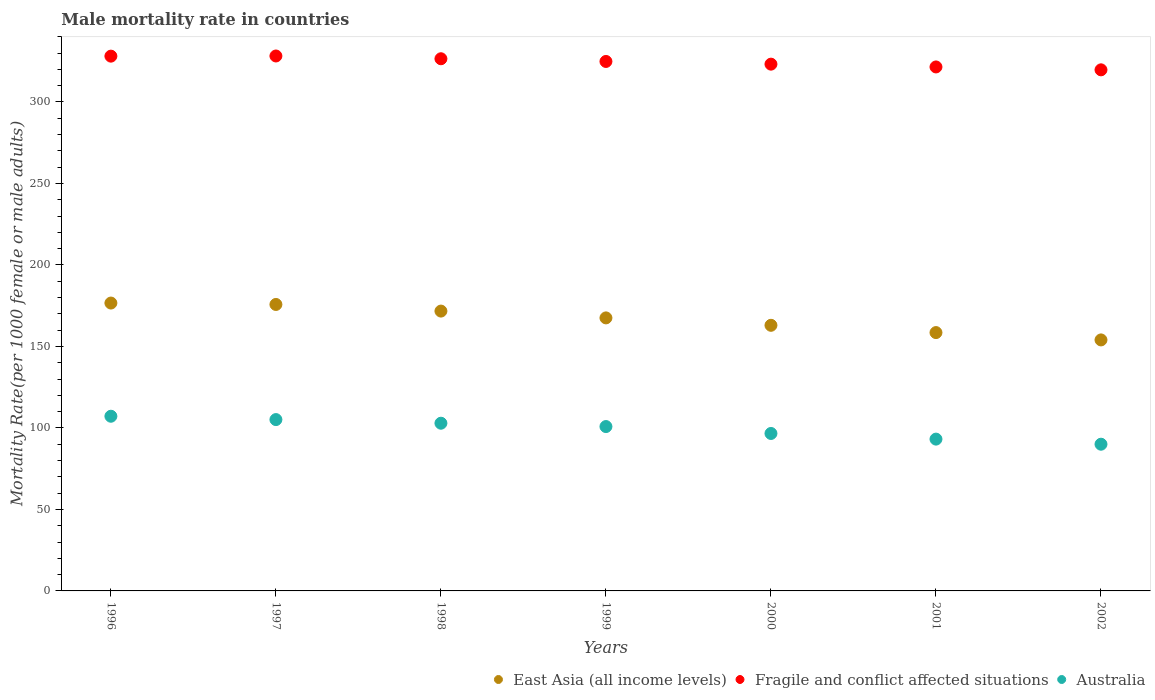How many different coloured dotlines are there?
Your response must be concise. 3. Is the number of dotlines equal to the number of legend labels?
Your response must be concise. Yes. What is the male mortality rate in Australia in 2001?
Your response must be concise. 93.13. Across all years, what is the maximum male mortality rate in Australia?
Provide a short and direct response. 107.17. Across all years, what is the minimum male mortality rate in East Asia (all income levels)?
Provide a short and direct response. 154. In which year was the male mortality rate in East Asia (all income levels) maximum?
Your response must be concise. 1996. What is the total male mortality rate in Australia in the graph?
Provide a succinct answer. 695.75. What is the difference between the male mortality rate in Australia in 1996 and that in 2000?
Offer a terse response. 10.57. What is the difference between the male mortality rate in Fragile and conflict affected situations in 1997 and the male mortality rate in Australia in 1999?
Your answer should be compact. 227.35. What is the average male mortality rate in Australia per year?
Your response must be concise. 99.39. In the year 2000, what is the difference between the male mortality rate in East Asia (all income levels) and male mortality rate in Fragile and conflict affected situations?
Keep it short and to the point. -160.22. What is the ratio of the male mortality rate in East Asia (all income levels) in 1997 to that in 1999?
Provide a short and direct response. 1.05. What is the difference between the highest and the second highest male mortality rate in East Asia (all income levels)?
Your answer should be compact. 0.86. What is the difference between the highest and the lowest male mortality rate in East Asia (all income levels)?
Offer a very short reply. 22.61. Is the sum of the male mortality rate in East Asia (all income levels) in 1996 and 1997 greater than the maximum male mortality rate in Australia across all years?
Ensure brevity in your answer.  Yes. Is it the case that in every year, the sum of the male mortality rate in Australia and male mortality rate in Fragile and conflict affected situations  is greater than the male mortality rate in East Asia (all income levels)?
Make the answer very short. Yes. Does the male mortality rate in East Asia (all income levels) monotonically increase over the years?
Provide a succinct answer. No. Is the male mortality rate in East Asia (all income levels) strictly less than the male mortality rate in Australia over the years?
Provide a succinct answer. No. How many years are there in the graph?
Keep it short and to the point. 7. What is the difference between two consecutive major ticks on the Y-axis?
Keep it short and to the point. 50. Are the values on the major ticks of Y-axis written in scientific E-notation?
Your answer should be very brief. No. Does the graph contain any zero values?
Your answer should be compact. No. Does the graph contain grids?
Give a very brief answer. No. Where does the legend appear in the graph?
Your answer should be very brief. Bottom right. What is the title of the graph?
Keep it short and to the point. Male mortality rate in countries. What is the label or title of the Y-axis?
Your response must be concise. Mortality Rate(per 1000 female or male adults). What is the Mortality Rate(per 1000 female or male adults) in East Asia (all income levels) in 1996?
Give a very brief answer. 176.61. What is the Mortality Rate(per 1000 female or male adults) of Fragile and conflict affected situations in 1996?
Keep it short and to the point. 328.09. What is the Mortality Rate(per 1000 female or male adults) in Australia in 1996?
Give a very brief answer. 107.17. What is the Mortality Rate(per 1000 female or male adults) in East Asia (all income levels) in 1997?
Your answer should be very brief. 175.75. What is the Mortality Rate(per 1000 female or male adults) in Fragile and conflict affected situations in 1997?
Provide a short and direct response. 328.19. What is the Mortality Rate(per 1000 female or male adults) of Australia in 1997?
Provide a succinct answer. 105.12. What is the Mortality Rate(per 1000 female or male adults) in East Asia (all income levels) in 1998?
Offer a very short reply. 171.68. What is the Mortality Rate(per 1000 female or male adults) of Fragile and conflict affected situations in 1998?
Your answer should be very brief. 326.5. What is the Mortality Rate(per 1000 female or male adults) in Australia in 1998?
Your answer should be compact. 102.89. What is the Mortality Rate(per 1000 female or male adults) in East Asia (all income levels) in 1999?
Your response must be concise. 167.51. What is the Mortality Rate(per 1000 female or male adults) in Fragile and conflict affected situations in 1999?
Provide a short and direct response. 324.84. What is the Mortality Rate(per 1000 female or male adults) in Australia in 1999?
Ensure brevity in your answer.  100.84. What is the Mortality Rate(per 1000 female or male adults) of East Asia (all income levels) in 2000?
Make the answer very short. 162.96. What is the Mortality Rate(per 1000 female or male adults) of Fragile and conflict affected situations in 2000?
Give a very brief answer. 323.18. What is the Mortality Rate(per 1000 female or male adults) in Australia in 2000?
Offer a terse response. 96.6. What is the Mortality Rate(per 1000 female or male adults) in East Asia (all income levels) in 2001?
Ensure brevity in your answer.  158.49. What is the Mortality Rate(per 1000 female or male adults) of Fragile and conflict affected situations in 2001?
Make the answer very short. 321.47. What is the Mortality Rate(per 1000 female or male adults) of Australia in 2001?
Ensure brevity in your answer.  93.13. What is the Mortality Rate(per 1000 female or male adults) in East Asia (all income levels) in 2002?
Offer a very short reply. 154. What is the Mortality Rate(per 1000 female or male adults) in Fragile and conflict affected situations in 2002?
Keep it short and to the point. 319.7. What is the Mortality Rate(per 1000 female or male adults) of Australia in 2002?
Your answer should be compact. 90.01. Across all years, what is the maximum Mortality Rate(per 1000 female or male adults) in East Asia (all income levels)?
Make the answer very short. 176.61. Across all years, what is the maximum Mortality Rate(per 1000 female or male adults) of Fragile and conflict affected situations?
Provide a short and direct response. 328.19. Across all years, what is the maximum Mortality Rate(per 1000 female or male adults) of Australia?
Give a very brief answer. 107.17. Across all years, what is the minimum Mortality Rate(per 1000 female or male adults) in East Asia (all income levels)?
Your answer should be very brief. 154. Across all years, what is the minimum Mortality Rate(per 1000 female or male adults) in Fragile and conflict affected situations?
Offer a terse response. 319.7. Across all years, what is the minimum Mortality Rate(per 1000 female or male adults) in Australia?
Your response must be concise. 90.01. What is the total Mortality Rate(per 1000 female or male adults) of East Asia (all income levels) in the graph?
Ensure brevity in your answer.  1167. What is the total Mortality Rate(per 1000 female or male adults) of Fragile and conflict affected situations in the graph?
Your answer should be very brief. 2271.97. What is the total Mortality Rate(per 1000 female or male adults) of Australia in the graph?
Ensure brevity in your answer.  695.75. What is the difference between the Mortality Rate(per 1000 female or male adults) of East Asia (all income levels) in 1996 and that in 1997?
Your answer should be very brief. 0.86. What is the difference between the Mortality Rate(per 1000 female or male adults) of Fragile and conflict affected situations in 1996 and that in 1997?
Ensure brevity in your answer.  -0.1. What is the difference between the Mortality Rate(per 1000 female or male adults) of Australia in 1996 and that in 1997?
Provide a succinct answer. 2.05. What is the difference between the Mortality Rate(per 1000 female or male adults) of East Asia (all income levels) in 1996 and that in 1998?
Your answer should be very brief. 4.93. What is the difference between the Mortality Rate(per 1000 female or male adults) in Fragile and conflict affected situations in 1996 and that in 1998?
Make the answer very short. 1.6. What is the difference between the Mortality Rate(per 1000 female or male adults) in Australia in 1996 and that in 1998?
Offer a very short reply. 4.28. What is the difference between the Mortality Rate(per 1000 female or male adults) of East Asia (all income levels) in 1996 and that in 1999?
Your response must be concise. 9.1. What is the difference between the Mortality Rate(per 1000 female or male adults) in Fragile and conflict affected situations in 1996 and that in 1999?
Provide a succinct answer. 3.26. What is the difference between the Mortality Rate(per 1000 female or male adults) in Australia in 1996 and that in 1999?
Your answer should be very brief. 6.33. What is the difference between the Mortality Rate(per 1000 female or male adults) in East Asia (all income levels) in 1996 and that in 2000?
Provide a succinct answer. 13.65. What is the difference between the Mortality Rate(per 1000 female or male adults) of Fragile and conflict affected situations in 1996 and that in 2000?
Offer a very short reply. 4.91. What is the difference between the Mortality Rate(per 1000 female or male adults) of Australia in 1996 and that in 2000?
Your response must be concise. 10.57. What is the difference between the Mortality Rate(per 1000 female or male adults) in East Asia (all income levels) in 1996 and that in 2001?
Your answer should be very brief. 18.12. What is the difference between the Mortality Rate(per 1000 female or male adults) of Fragile and conflict affected situations in 1996 and that in 2001?
Provide a succinct answer. 6.62. What is the difference between the Mortality Rate(per 1000 female or male adults) in Australia in 1996 and that in 2001?
Make the answer very short. 14.03. What is the difference between the Mortality Rate(per 1000 female or male adults) in East Asia (all income levels) in 1996 and that in 2002?
Your response must be concise. 22.61. What is the difference between the Mortality Rate(per 1000 female or male adults) of Fragile and conflict affected situations in 1996 and that in 2002?
Give a very brief answer. 8.4. What is the difference between the Mortality Rate(per 1000 female or male adults) in Australia in 1996 and that in 2002?
Ensure brevity in your answer.  17.16. What is the difference between the Mortality Rate(per 1000 female or male adults) of East Asia (all income levels) in 1997 and that in 1998?
Provide a succinct answer. 4.07. What is the difference between the Mortality Rate(per 1000 female or male adults) in Fragile and conflict affected situations in 1997 and that in 1998?
Ensure brevity in your answer.  1.7. What is the difference between the Mortality Rate(per 1000 female or male adults) of Australia in 1997 and that in 1998?
Keep it short and to the point. 2.23. What is the difference between the Mortality Rate(per 1000 female or male adults) in East Asia (all income levels) in 1997 and that in 1999?
Provide a short and direct response. 8.24. What is the difference between the Mortality Rate(per 1000 female or male adults) in Fragile and conflict affected situations in 1997 and that in 1999?
Offer a terse response. 3.35. What is the difference between the Mortality Rate(per 1000 female or male adults) in Australia in 1997 and that in 1999?
Your response must be concise. 4.28. What is the difference between the Mortality Rate(per 1000 female or male adults) of East Asia (all income levels) in 1997 and that in 2000?
Keep it short and to the point. 12.79. What is the difference between the Mortality Rate(per 1000 female or male adults) in Fragile and conflict affected situations in 1997 and that in 2000?
Ensure brevity in your answer.  5.01. What is the difference between the Mortality Rate(per 1000 female or male adults) of Australia in 1997 and that in 2000?
Provide a succinct answer. 8.52. What is the difference between the Mortality Rate(per 1000 female or male adults) in East Asia (all income levels) in 1997 and that in 2001?
Provide a short and direct response. 17.25. What is the difference between the Mortality Rate(per 1000 female or male adults) of Fragile and conflict affected situations in 1997 and that in 2001?
Keep it short and to the point. 6.72. What is the difference between the Mortality Rate(per 1000 female or male adults) of Australia in 1997 and that in 2001?
Your answer should be very brief. 11.99. What is the difference between the Mortality Rate(per 1000 female or male adults) in East Asia (all income levels) in 1997 and that in 2002?
Make the answer very short. 21.75. What is the difference between the Mortality Rate(per 1000 female or male adults) of Fragile and conflict affected situations in 1997 and that in 2002?
Give a very brief answer. 8.5. What is the difference between the Mortality Rate(per 1000 female or male adults) of Australia in 1997 and that in 2002?
Give a very brief answer. 15.11. What is the difference between the Mortality Rate(per 1000 female or male adults) in East Asia (all income levels) in 1998 and that in 1999?
Your answer should be compact. 4.17. What is the difference between the Mortality Rate(per 1000 female or male adults) in Fragile and conflict affected situations in 1998 and that in 1999?
Offer a terse response. 1.66. What is the difference between the Mortality Rate(per 1000 female or male adults) of Australia in 1998 and that in 1999?
Ensure brevity in your answer.  2.05. What is the difference between the Mortality Rate(per 1000 female or male adults) in East Asia (all income levels) in 1998 and that in 2000?
Ensure brevity in your answer.  8.72. What is the difference between the Mortality Rate(per 1000 female or male adults) in Fragile and conflict affected situations in 1998 and that in 2000?
Your answer should be very brief. 3.32. What is the difference between the Mortality Rate(per 1000 female or male adults) of Australia in 1998 and that in 2000?
Offer a very short reply. 6.29. What is the difference between the Mortality Rate(per 1000 female or male adults) in East Asia (all income levels) in 1998 and that in 2001?
Your response must be concise. 13.19. What is the difference between the Mortality Rate(per 1000 female or male adults) of Fragile and conflict affected situations in 1998 and that in 2001?
Ensure brevity in your answer.  5.03. What is the difference between the Mortality Rate(per 1000 female or male adults) in Australia in 1998 and that in 2001?
Offer a terse response. 9.75. What is the difference between the Mortality Rate(per 1000 female or male adults) of East Asia (all income levels) in 1998 and that in 2002?
Offer a terse response. 17.68. What is the difference between the Mortality Rate(per 1000 female or male adults) of Fragile and conflict affected situations in 1998 and that in 2002?
Give a very brief answer. 6.8. What is the difference between the Mortality Rate(per 1000 female or male adults) in Australia in 1998 and that in 2002?
Provide a short and direct response. 12.88. What is the difference between the Mortality Rate(per 1000 female or male adults) in East Asia (all income levels) in 1999 and that in 2000?
Your response must be concise. 4.55. What is the difference between the Mortality Rate(per 1000 female or male adults) in Fragile and conflict affected situations in 1999 and that in 2000?
Give a very brief answer. 1.66. What is the difference between the Mortality Rate(per 1000 female or male adults) of Australia in 1999 and that in 2000?
Give a very brief answer. 4.24. What is the difference between the Mortality Rate(per 1000 female or male adults) of East Asia (all income levels) in 1999 and that in 2001?
Make the answer very short. 9.02. What is the difference between the Mortality Rate(per 1000 female or male adults) of Fragile and conflict affected situations in 1999 and that in 2001?
Keep it short and to the point. 3.37. What is the difference between the Mortality Rate(per 1000 female or male adults) in Australia in 1999 and that in 2001?
Offer a very short reply. 7.71. What is the difference between the Mortality Rate(per 1000 female or male adults) in East Asia (all income levels) in 1999 and that in 2002?
Offer a terse response. 13.51. What is the difference between the Mortality Rate(per 1000 female or male adults) in Fragile and conflict affected situations in 1999 and that in 2002?
Your answer should be very brief. 5.14. What is the difference between the Mortality Rate(per 1000 female or male adults) in Australia in 1999 and that in 2002?
Your answer should be compact. 10.83. What is the difference between the Mortality Rate(per 1000 female or male adults) of East Asia (all income levels) in 2000 and that in 2001?
Give a very brief answer. 4.47. What is the difference between the Mortality Rate(per 1000 female or male adults) of Fragile and conflict affected situations in 2000 and that in 2001?
Your response must be concise. 1.71. What is the difference between the Mortality Rate(per 1000 female or male adults) of Australia in 2000 and that in 2001?
Provide a succinct answer. 3.46. What is the difference between the Mortality Rate(per 1000 female or male adults) in East Asia (all income levels) in 2000 and that in 2002?
Provide a short and direct response. 8.96. What is the difference between the Mortality Rate(per 1000 female or male adults) of Fragile and conflict affected situations in 2000 and that in 2002?
Your response must be concise. 3.49. What is the difference between the Mortality Rate(per 1000 female or male adults) in Australia in 2000 and that in 2002?
Offer a very short reply. 6.59. What is the difference between the Mortality Rate(per 1000 female or male adults) in East Asia (all income levels) in 2001 and that in 2002?
Your response must be concise. 4.5. What is the difference between the Mortality Rate(per 1000 female or male adults) in Fragile and conflict affected situations in 2001 and that in 2002?
Provide a succinct answer. 1.77. What is the difference between the Mortality Rate(per 1000 female or male adults) in Australia in 2001 and that in 2002?
Provide a short and direct response. 3.13. What is the difference between the Mortality Rate(per 1000 female or male adults) of East Asia (all income levels) in 1996 and the Mortality Rate(per 1000 female or male adults) of Fragile and conflict affected situations in 1997?
Keep it short and to the point. -151.58. What is the difference between the Mortality Rate(per 1000 female or male adults) in East Asia (all income levels) in 1996 and the Mortality Rate(per 1000 female or male adults) in Australia in 1997?
Ensure brevity in your answer.  71.49. What is the difference between the Mortality Rate(per 1000 female or male adults) in Fragile and conflict affected situations in 1996 and the Mortality Rate(per 1000 female or male adults) in Australia in 1997?
Offer a terse response. 222.97. What is the difference between the Mortality Rate(per 1000 female or male adults) of East Asia (all income levels) in 1996 and the Mortality Rate(per 1000 female or male adults) of Fragile and conflict affected situations in 1998?
Ensure brevity in your answer.  -149.89. What is the difference between the Mortality Rate(per 1000 female or male adults) of East Asia (all income levels) in 1996 and the Mortality Rate(per 1000 female or male adults) of Australia in 1998?
Your answer should be compact. 73.72. What is the difference between the Mortality Rate(per 1000 female or male adults) in Fragile and conflict affected situations in 1996 and the Mortality Rate(per 1000 female or male adults) in Australia in 1998?
Offer a terse response. 225.21. What is the difference between the Mortality Rate(per 1000 female or male adults) of East Asia (all income levels) in 1996 and the Mortality Rate(per 1000 female or male adults) of Fragile and conflict affected situations in 1999?
Offer a very short reply. -148.23. What is the difference between the Mortality Rate(per 1000 female or male adults) in East Asia (all income levels) in 1996 and the Mortality Rate(per 1000 female or male adults) in Australia in 1999?
Give a very brief answer. 75.77. What is the difference between the Mortality Rate(per 1000 female or male adults) in Fragile and conflict affected situations in 1996 and the Mortality Rate(per 1000 female or male adults) in Australia in 1999?
Provide a succinct answer. 227.25. What is the difference between the Mortality Rate(per 1000 female or male adults) in East Asia (all income levels) in 1996 and the Mortality Rate(per 1000 female or male adults) in Fragile and conflict affected situations in 2000?
Provide a succinct answer. -146.57. What is the difference between the Mortality Rate(per 1000 female or male adults) of East Asia (all income levels) in 1996 and the Mortality Rate(per 1000 female or male adults) of Australia in 2000?
Your answer should be compact. 80.01. What is the difference between the Mortality Rate(per 1000 female or male adults) of Fragile and conflict affected situations in 1996 and the Mortality Rate(per 1000 female or male adults) of Australia in 2000?
Offer a very short reply. 231.5. What is the difference between the Mortality Rate(per 1000 female or male adults) of East Asia (all income levels) in 1996 and the Mortality Rate(per 1000 female or male adults) of Fragile and conflict affected situations in 2001?
Offer a terse response. -144.86. What is the difference between the Mortality Rate(per 1000 female or male adults) of East Asia (all income levels) in 1996 and the Mortality Rate(per 1000 female or male adults) of Australia in 2001?
Provide a short and direct response. 83.48. What is the difference between the Mortality Rate(per 1000 female or male adults) of Fragile and conflict affected situations in 1996 and the Mortality Rate(per 1000 female or male adults) of Australia in 2001?
Ensure brevity in your answer.  234.96. What is the difference between the Mortality Rate(per 1000 female or male adults) of East Asia (all income levels) in 1996 and the Mortality Rate(per 1000 female or male adults) of Fragile and conflict affected situations in 2002?
Provide a short and direct response. -143.09. What is the difference between the Mortality Rate(per 1000 female or male adults) in East Asia (all income levels) in 1996 and the Mortality Rate(per 1000 female or male adults) in Australia in 2002?
Offer a very short reply. 86.6. What is the difference between the Mortality Rate(per 1000 female or male adults) in Fragile and conflict affected situations in 1996 and the Mortality Rate(per 1000 female or male adults) in Australia in 2002?
Keep it short and to the point. 238.09. What is the difference between the Mortality Rate(per 1000 female or male adults) of East Asia (all income levels) in 1997 and the Mortality Rate(per 1000 female or male adults) of Fragile and conflict affected situations in 1998?
Make the answer very short. -150.75. What is the difference between the Mortality Rate(per 1000 female or male adults) of East Asia (all income levels) in 1997 and the Mortality Rate(per 1000 female or male adults) of Australia in 1998?
Offer a terse response. 72.86. What is the difference between the Mortality Rate(per 1000 female or male adults) of Fragile and conflict affected situations in 1997 and the Mortality Rate(per 1000 female or male adults) of Australia in 1998?
Your answer should be very brief. 225.31. What is the difference between the Mortality Rate(per 1000 female or male adults) in East Asia (all income levels) in 1997 and the Mortality Rate(per 1000 female or male adults) in Fragile and conflict affected situations in 1999?
Offer a very short reply. -149.09. What is the difference between the Mortality Rate(per 1000 female or male adults) in East Asia (all income levels) in 1997 and the Mortality Rate(per 1000 female or male adults) in Australia in 1999?
Provide a succinct answer. 74.91. What is the difference between the Mortality Rate(per 1000 female or male adults) in Fragile and conflict affected situations in 1997 and the Mortality Rate(per 1000 female or male adults) in Australia in 1999?
Make the answer very short. 227.35. What is the difference between the Mortality Rate(per 1000 female or male adults) of East Asia (all income levels) in 1997 and the Mortality Rate(per 1000 female or male adults) of Fragile and conflict affected situations in 2000?
Give a very brief answer. -147.43. What is the difference between the Mortality Rate(per 1000 female or male adults) of East Asia (all income levels) in 1997 and the Mortality Rate(per 1000 female or male adults) of Australia in 2000?
Keep it short and to the point. 79.15. What is the difference between the Mortality Rate(per 1000 female or male adults) of Fragile and conflict affected situations in 1997 and the Mortality Rate(per 1000 female or male adults) of Australia in 2000?
Give a very brief answer. 231.59. What is the difference between the Mortality Rate(per 1000 female or male adults) in East Asia (all income levels) in 1997 and the Mortality Rate(per 1000 female or male adults) in Fragile and conflict affected situations in 2001?
Make the answer very short. -145.72. What is the difference between the Mortality Rate(per 1000 female or male adults) in East Asia (all income levels) in 1997 and the Mortality Rate(per 1000 female or male adults) in Australia in 2001?
Your response must be concise. 82.61. What is the difference between the Mortality Rate(per 1000 female or male adults) of Fragile and conflict affected situations in 1997 and the Mortality Rate(per 1000 female or male adults) of Australia in 2001?
Give a very brief answer. 235.06. What is the difference between the Mortality Rate(per 1000 female or male adults) of East Asia (all income levels) in 1997 and the Mortality Rate(per 1000 female or male adults) of Fragile and conflict affected situations in 2002?
Your answer should be compact. -143.95. What is the difference between the Mortality Rate(per 1000 female or male adults) of East Asia (all income levels) in 1997 and the Mortality Rate(per 1000 female or male adults) of Australia in 2002?
Ensure brevity in your answer.  85.74. What is the difference between the Mortality Rate(per 1000 female or male adults) in Fragile and conflict affected situations in 1997 and the Mortality Rate(per 1000 female or male adults) in Australia in 2002?
Keep it short and to the point. 238.19. What is the difference between the Mortality Rate(per 1000 female or male adults) in East Asia (all income levels) in 1998 and the Mortality Rate(per 1000 female or male adults) in Fragile and conflict affected situations in 1999?
Your answer should be very brief. -153.16. What is the difference between the Mortality Rate(per 1000 female or male adults) in East Asia (all income levels) in 1998 and the Mortality Rate(per 1000 female or male adults) in Australia in 1999?
Your answer should be compact. 70.84. What is the difference between the Mortality Rate(per 1000 female or male adults) of Fragile and conflict affected situations in 1998 and the Mortality Rate(per 1000 female or male adults) of Australia in 1999?
Your answer should be very brief. 225.66. What is the difference between the Mortality Rate(per 1000 female or male adults) of East Asia (all income levels) in 1998 and the Mortality Rate(per 1000 female or male adults) of Fragile and conflict affected situations in 2000?
Your response must be concise. -151.5. What is the difference between the Mortality Rate(per 1000 female or male adults) of East Asia (all income levels) in 1998 and the Mortality Rate(per 1000 female or male adults) of Australia in 2000?
Offer a very short reply. 75.08. What is the difference between the Mortality Rate(per 1000 female or male adults) of Fragile and conflict affected situations in 1998 and the Mortality Rate(per 1000 female or male adults) of Australia in 2000?
Your answer should be compact. 229.9. What is the difference between the Mortality Rate(per 1000 female or male adults) of East Asia (all income levels) in 1998 and the Mortality Rate(per 1000 female or male adults) of Fragile and conflict affected situations in 2001?
Offer a terse response. -149.79. What is the difference between the Mortality Rate(per 1000 female or male adults) of East Asia (all income levels) in 1998 and the Mortality Rate(per 1000 female or male adults) of Australia in 2001?
Provide a succinct answer. 78.55. What is the difference between the Mortality Rate(per 1000 female or male adults) of Fragile and conflict affected situations in 1998 and the Mortality Rate(per 1000 female or male adults) of Australia in 2001?
Make the answer very short. 233.36. What is the difference between the Mortality Rate(per 1000 female or male adults) of East Asia (all income levels) in 1998 and the Mortality Rate(per 1000 female or male adults) of Fragile and conflict affected situations in 2002?
Offer a very short reply. -148.01. What is the difference between the Mortality Rate(per 1000 female or male adults) of East Asia (all income levels) in 1998 and the Mortality Rate(per 1000 female or male adults) of Australia in 2002?
Offer a very short reply. 81.68. What is the difference between the Mortality Rate(per 1000 female or male adults) in Fragile and conflict affected situations in 1998 and the Mortality Rate(per 1000 female or male adults) in Australia in 2002?
Offer a terse response. 236.49. What is the difference between the Mortality Rate(per 1000 female or male adults) in East Asia (all income levels) in 1999 and the Mortality Rate(per 1000 female or male adults) in Fragile and conflict affected situations in 2000?
Keep it short and to the point. -155.67. What is the difference between the Mortality Rate(per 1000 female or male adults) in East Asia (all income levels) in 1999 and the Mortality Rate(per 1000 female or male adults) in Australia in 2000?
Make the answer very short. 70.91. What is the difference between the Mortality Rate(per 1000 female or male adults) in Fragile and conflict affected situations in 1999 and the Mortality Rate(per 1000 female or male adults) in Australia in 2000?
Offer a terse response. 228.24. What is the difference between the Mortality Rate(per 1000 female or male adults) in East Asia (all income levels) in 1999 and the Mortality Rate(per 1000 female or male adults) in Fragile and conflict affected situations in 2001?
Keep it short and to the point. -153.96. What is the difference between the Mortality Rate(per 1000 female or male adults) in East Asia (all income levels) in 1999 and the Mortality Rate(per 1000 female or male adults) in Australia in 2001?
Your answer should be very brief. 74.37. What is the difference between the Mortality Rate(per 1000 female or male adults) of Fragile and conflict affected situations in 1999 and the Mortality Rate(per 1000 female or male adults) of Australia in 2001?
Your answer should be very brief. 231.7. What is the difference between the Mortality Rate(per 1000 female or male adults) in East Asia (all income levels) in 1999 and the Mortality Rate(per 1000 female or male adults) in Fragile and conflict affected situations in 2002?
Your response must be concise. -152.19. What is the difference between the Mortality Rate(per 1000 female or male adults) in East Asia (all income levels) in 1999 and the Mortality Rate(per 1000 female or male adults) in Australia in 2002?
Your response must be concise. 77.5. What is the difference between the Mortality Rate(per 1000 female or male adults) in Fragile and conflict affected situations in 1999 and the Mortality Rate(per 1000 female or male adults) in Australia in 2002?
Ensure brevity in your answer.  234.83. What is the difference between the Mortality Rate(per 1000 female or male adults) of East Asia (all income levels) in 2000 and the Mortality Rate(per 1000 female or male adults) of Fragile and conflict affected situations in 2001?
Your answer should be very brief. -158.51. What is the difference between the Mortality Rate(per 1000 female or male adults) in East Asia (all income levels) in 2000 and the Mortality Rate(per 1000 female or male adults) in Australia in 2001?
Offer a terse response. 69.83. What is the difference between the Mortality Rate(per 1000 female or male adults) in Fragile and conflict affected situations in 2000 and the Mortality Rate(per 1000 female or male adults) in Australia in 2001?
Provide a short and direct response. 230.05. What is the difference between the Mortality Rate(per 1000 female or male adults) in East Asia (all income levels) in 2000 and the Mortality Rate(per 1000 female or male adults) in Fragile and conflict affected situations in 2002?
Offer a very short reply. -156.73. What is the difference between the Mortality Rate(per 1000 female or male adults) in East Asia (all income levels) in 2000 and the Mortality Rate(per 1000 female or male adults) in Australia in 2002?
Offer a terse response. 72.96. What is the difference between the Mortality Rate(per 1000 female or male adults) in Fragile and conflict affected situations in 2000 and the Mortality Rate(per 1000 female or male adults) in Australia in 2002?
Your answer should be compact. 233.17. What is the difference between the Mortality Rate(per 1000 female or male adults) in East Asia (all income levels) in 2001 and the Mortality Rate(per 1000 female or male adults) in Fragile and conflict affected situations in 2002?
Provide a succinct answer. -161.2. What is the difference between the Mortality Rate(per 1000 female or male adults) of East Asia (all income levels) in 2001 and the Mortality Rate(per 1000 female or male adults) of Australia in 2002?
Provide a succinct answer. 68.49. What is the difference between the Mortality Rate(per 1000 female or male adults) in Fragile and conflict affected situations in 2001 and the Mortality Rate(per 1000 female or male adults) in Australia in 2002?
Your response must be concise. 231.46. What is the average Mortality Rate(per 1000 female or male adults) in East Asia (all income levels) per year?
Keep it short and to the point. 166.71. What is the average Mortality Rate(per 1000 female or male adults) of Fragile and conflict affected situations per year?
Ensure brevity in your answer.  324.57. What is the average Mortality Rate(per 1000 female or male adults) of Australia per year?
Make the answer very short. 99.39. In the year 1996, what is the difference between the Mortality Rate(per 1000 female or male adults) of East Asia (all income levels) and Mortality Rate(per 1000 female or male adults) of Fragile and conflict affected situations?
Your answer should be compact. -151.48. In the year 1996, what is the difference between the Mortality Rate(per 1000 female or male adults) in East Asia (all income levels) and Mortality Rate(per 1000 female or male adults) in Australia?
Offer a very short reply. 69.44. In the year 1996, what is the difference between the Mortality Rate(per 1000 female or male adults) in Fragile and conflict affected situations and Mortality Rate(per 1000 female or male adults) in Australia?
Make the answer very short. 220.93. In the year 1997, what is the difference between the Mortality Rate(per 1000 female or male adults) of East Asia (all income levels) and Mortality Rate(per 1000 female or male adults) of Fragile and conflict affected situations?
Offer a terse response. -152.44. In the year 1997, what is the difference between the Mortality Rate(per 1000 female or male adults) in East Asia (all income levels) and Mortality Rate(per 1000 female or male adults) in Australia?
Keep it short and to the point. 70.63. In the year 1997, what is the difference between the Mortality Rate(per 1000 female or male adults) in Fragile and conflict affected situations and Mortality Rate(per 1000 female or male adults) in Australia?
Provide a succinct answer. 223.07. In the year 1998, what is the difference between the Mortality Rate(per 1000 female or male adults) in East Asia (all income levels) and Mortality Rate(per 1000 female or male adults) in Fragile and conflict affected situations?
Give a very brief answer. -154.81. In the year 1998, what is the difference between the Mortality Rate(per 1000 female or male adults) of East Asia (all income levels) and Mortality Rate(per 1000 female or male adults) of Australia?
Make the answer very short. 68.8. In the year 1998, what is the difference between the Mortality Rate(per 1000 female or male adults) of Fragile and conflict affected situations and Mortality Rate(per 1000 female or male adults) of Australia?
Keep it short and to the point. 223.61. In the year 1999, what is the difference between the Mortality Rate(per 1000 female or male adults) of East Asia (all income levels) and Mortality Rate(per 1000 female or male adults) of Fragile and conflict affected situations?
Your answer should be very brief. -157.33. In the year 1999, what is the difference between the Mortality Rate(per 1000 female or male adults) in East Asia (all income levels) and Mortality Rate(per 1000 female or male adults) in Australia?
Give a very brief answer. 66.67. In the year 1999, what is the difference between the Mortality Rate(per 1000 female or male adults) of Fragile and conflict affected situations and Mortality Rate(per 1000 female or male adults) of Australia?
Ensure brevity in your answer.  224. In the year 2000, what is the difference between the Mortality Rate(per 1000 female or male adults) of East Asia (all income levels) and Mortality Rate(per 1000 female or male adults) of Fragile and conflict affected situations?
Offer a terse response. -160.22. In the year 2000, what is the difference between the Mortality Rate(per 1000 female or male adults) in East Asia (all income levels) and Mortality Rate(per 1000 female or male adults) in Australia?
Offer a very short reply. 66.36. In the year 2000, what is the difference between the Mortality Rate(per 1000 female or male adults) of Fragile and conflict affected situations and Mortality Rate(per 1000 female or male adults) of Australia?
Your answer should be compact. 226.58. In the year 2001, what is the difference between the Mortality Rate(per 1000 female or male adults) of East Asia (all income levels) and Mortality Rate(per 1000 female or male adults) of Fragile and conflict affected situations?
Offer a terse response. -162.98. In the year 2001, what is the difference between the Mortality Rate(per 1000 female or male adults) of East Asia (all income levels) and Mortality Rate(per 1000 female or male adults) of Australia?
Offer a very short reply. 65.36. In the year 2001, what is the difference between the Mortality Rate(per 1000 female or male adults) in Fragile and conflict affected situations and Mortality Rate(per 1000 female or male adults) in Australia?
Offer a terse response. 228.34. In the year 2002, what is the difference between the Mortality Rate(per 1000 female or male adults) in East Asia (all income levels) and Mortality Rate(per 1000 female or male adults) in Fragile and conflict affected situations?
Provide a short and direct response. -165.7. In the year 2002, what is the difference between the Mortality Rate(per 1000 female or male adults) of East Asia (all income levels) and Mortality Rate(per 1000 female or male adults) of Australia?
Your response must be concise. 63.99. In the year 2002, what is the difference between the Mortality Rate(per 1000 female or male adults) of Fragile and conflict affected situations and Mortality Rate(per 1000 female or male adults) of Australia?
Your answer should be compact. 229.69. What is the ratio of the Mortality Rate(per 1000 female or male adults) in East Asia (all income levels) in 1996 to that in 1997?
Provide a succinct answer. 1. What is the ratio of the Mortality Rate(per 1000 female or male adults) of Australia in 1996 to that in 1997?
Offer a terse response. 1.02. What is the ratio of the Mortality Rate(per 1000 female or male adults) in East Asia (all income levels) in 1996 to that in 1998?
Provide a succinct answer. 1.03. What is the ratio of the Mortality Rate(per 1000 female or male adults) of Australia in 1996 to that in 1998?
Keep it short and to the point. 1.04. What is the ratio of the Mortality Rate(per 1000 female or male adults) in East Asia (all income levels) in 1996 to that in 1999?
Provide a succinct answer. 1.05. What is the ratio of the Mortality Rate(per 1000 female or male adults) of Australia in 1996 to that in 1999?
Offer a terse response. 1.06. What is the ratio of the Mortality Rate(per 1000 female or male adults) in East Asia (all income levels) in 1996 to that in 2000?
Your answer should be compact. 1.08. What is the ratio of the Mortality Rate(per 1000 female or male adults) in Fragile and conflict affected situations in 1996 to that in 2000?
Provide a succinct answer. 1.02. What is the ratio of the Mortality Rate(per 1000 female or male adults) in Australia in 1996 to that in 2000?
Make the answer very short. 1.11. What is the ratio of the Mortality Rate(per 1000 female or male adults) of East Asia (all income levels) in 1996 to that in 2001?
Provide a short and direct response. 1.11. What is the ratio of the Mortality Rate(per 1000 female or male adults) in Fragile and conflict affected situations in 1996 to that in 2001?
Make the answer very short. 1.02. What is the ratio of the Mortality Rate(per 1000 female or male adults) in Australia in 1996 to that in 2001?
Ensure brevity in your answer.  1.15. What is the ratio of the Mortality Rate(per 1000 female or male adults) of East Asia (all income levels) in 1996 to that in 2002?
Provide a succinct answer. 1.15. What is the ratio of the Mortality Rate(per 1000 female or male adults) of Fragile and conflict affected situations in 1996 to that in 2002?
Give a very brief answer. 1.03. What is the ratio of the Mortality Rate(per 1000 female or male adults) of Australia in 1996 to that in 2002?
Provide a short and direct response. 1.19. What is the ratio of the Mortality Rate(per 1000 female or male adults) of East Asia (all income levels) in 1997 to that in 1998?
Make the answer very short. 1.02. What is the ratio of the Mortality Rate(per 1000 female or male adults) of Australia in 1997 to that in 1998?
Your answer should be compact. 1.02. What is the ratio of the Mortality Rate(per 1000 female or male adults) of East Asia (all income levels) in 1997 to that in 1999?
Your answer should be very brief. 1.05. What is the ratio of the Mortality Rate(per 1000 female or male adults) in Fragile and conflict affected situations in 1997 to that in 1999?
Keep it short and to the point. 1.01. What is the ratio of the Mortality Rate(per 1000 female or male adults) of Australia in 1997 to that in 1999?
Your answer should be compact. 1.04. What is the ratio of the Mortality Rate(per 1000 female or male adults) in East Asia (all income levels) in 1997 to that in 2000?
Your answer should be compact. 1.08. What is the ratio of the Mortality Rate(per 1000 female or male adults) in Fragile and conflict affected situations in 1997 to that in 2000?
Give a very brief answer. 1.02. What is the ratio of the Mortality Rate(per 1000 female or male adults) of Australia in 1997 to that in 2000?
Ensure brevity in your answer.  1.09. What is the ratio of the Mortality Rate(per 1000 female or male adults) of East Asia (all income levels) in 1997 to that in 2001?
Give a very brief answer. 1.11. What is the ratio of the Mortality Rate(per 1000 female or male adults) of Fragile and conflict affected situations in 1997 to that in 2001?
Your answer should be very brief. 1.02. What is the ratio of the Mortality Rate(per 1000 female or male adults) of Australia in 1997 to that in 2001?
Provide a succinct answer. 1.13. What is the ratio of the Mortality Rate(per 1000 female or male adults) of East Asia (all income levels) in 1997 to that in 2002?
Offer a very short reply. 1.14. What is the ratio of the Mortality Rate(per 1000 female or male adults) in Fragile and conflict affected situations in 1997 to that in 2002?
Provide a short and direct response. 1.03. What is the ratio of the Mortality Rate(per 1000 female or male adults) in Australia in 1997 to that in 2002?
Your answer should be very brief. 1.17. What is the ratio of the Mortality Rate(per 1000 female or male adults) of East Asia (all income levels) in 1998 to that in 1999?
Keep it short and to the point. 1.02. What is the ratio of the Mortality Rate(per 1000 female or male adults) in Australia in 1998 to that in 1999?
Offer a very short reply. 1.02. What is the ratio of the Mortality Rate(per 1000 female or male adults) in East Asia (all income levels) in 1998 to that in 2000?
Provide a short and direct response. 1.05. What is the ratio of the Mortality Rate(per 1000 female or male adults) of Fragile and conflict affected situations in 1998 to that in 2000?
Make the answer very short. 1.01. What is the ratio of the Mortality Rate(per 1000 female or male adults) in Australia in 1998 to that in 2000?
Give a very brief answer. 1.07. What is the ratio of the Mortality Rate(per 1000 female or male adults) in East Asia (all income levels) in 1998 to that in 2001?
Ensure brevity in your answer.  1.08. What is the ratio of the Mortality Rate(per 1000 female or male adults) in Fragile and conflict affected situations in 1998 to that in 2001?
Offer a very short reply. 1.02. What is the ratio of the Mortality Rate(per 1000 female or male adults) in Australia in 1998 to that in 2001?
Offer a terse response. 1.1. What is the ratio of the Mortality Rate(per 1000 female or male adults) of East Asia (all income levels) in 1998 to that in 2002?
Offer a terse response. 1.11. What is the ratio of the Mortality Rate(per 1000 female or male adults) in Fragile and conflict affected situations in 1998 to that in 2002?
Provide a succinct answer. 1.02. What is the ratio of the Mortality Rate(per 1000 female or male adults) in Australia in 1998 to that in 2002?
Your response must be concise. 1.14. What is the ratio of the Mortality Rate(per 1000 female or male adults) of East Asia (all income levels) in 1999 to that in 2000?
Offer a terse response. 1.03. What is the ratio of the Mortality Rate(per 1000 female or male adults) of Fragile and conflict affected situations in 1999 to that in 2000?
Your response must be concise. 1.01. What is the ratio of the Mortality Rate(per 1000 female or male adults) of Australia in 1999 to that in 2000?
Provide a short and direct response. 1.04. What is the ratio of the Mortality Rate(per 1000 female or male adults) in East Asia (all income levels) in 1999 to that in 2001?
Make the answer very short. 1.06. What is the ratio of the Mortality Rate(per 1000 female or male adults) of Fragile and conflict affected situations in 1999 to that in 2001?
Offer a terse response. 1.01. What is the ratio of the Mortality Rate(per 1000 female or male adults) of Australia in 1999 to that in 2001?
Provide a short and direct response. 1.08. What is the ratio of the Mortality Rate(per 1000 female or male adults) of East Asia (all income levels) in 1999 to that in 2002?
Offer a very short reply. 1.09. What is the ratio of the Mortality Rate(per 1000 female or male adults) of Fragile and conflict affected situations in 1999 to that in 2002?
Your answer should be compact. 1.02. What is the ratio of the Mortality Rate(per 1000 female or male adults) of Australia in 1999 to that in 2002?
Offer a terse response. 1.12. What is the ratio of the Mortality Rate(per 1000 female or male adults) of East Asia (all income levels) in 2000 to that in 2001?
Your answer should be compact. 1.03. What is the ratio of the Mortality Rate(per 1000 female or male adults) in Fragile and conflict affected situations in 2000 to that in 2001?
Offer a terse response. 1.01. What is the ratio of the Mortality Rate(per 1000 female or male adults) in Australia in 2000 to that in 2001?
Your response must be concise. 1.04. What is the ratio of the Mortality Rate(per 1000 female or male adults) in East Asia (all income levels) in 2000 to that in 2002?
Your response must be concise. 1.06. What is the ratio of the Mortality Rate(per 1000 female or male adults) of Fragile and conflict affected situations in 2000 to that in 2002?
Your answer should be compact. 1.01. What is the ratio of the Mortality Rate(per 1000 female or male adults) of Australia in 2000 to that in 2002?
Your answer should be very brief. 1.07. What is the ratio of the Mortality Rate(per 1000 female or male adults) of East Asia (all income levels) in 2001 to that in 2002?
Offer a terse response. 1.03. What is the ratio of the Mortality Rate(per 1000 female or male adults) in Fragile and conflict affected situations in 2001 to that in 2002?
Your answer should be compact. 1.01. What is the ratio of the Mortality Rate(per 1000 female or male adults) in Australia in 2001 to that in 2002?
Your answer should be very brief. 1.03. What is the difference between the highest and the second highest Mortality Rate(per 1000 female or male adults) in East Asia (all income levels)?
Offer a very short reply. 0.86. What is the difference between the highest and the second highest Mortality Rate(per 1000 female or male adults) of Fragile and conflict affected situations?
Provide a succinct answer. 0.1. What is the difference between the highest and the second highest Mortality Rate(per 1000 female or male adults) of Australia?
Make the answer very short. 2.05. What is the difference between the highest and the lowest Mortality Rate(per 1000 female or male adults) of East Asia (all income levels)?
Your answer should be compact. 22.61. What is the difference between the highest and the lowest Mortality Rate(per 1000 female or male adults) in Fragile and conflict affected situations?
Ensure brevity in your answer.  8.5. What is the difference between the highest and the lowest Mortality Rate(per 1000 female or male adults) of Australia?
Ensure brevity in your answer.  17.16. 